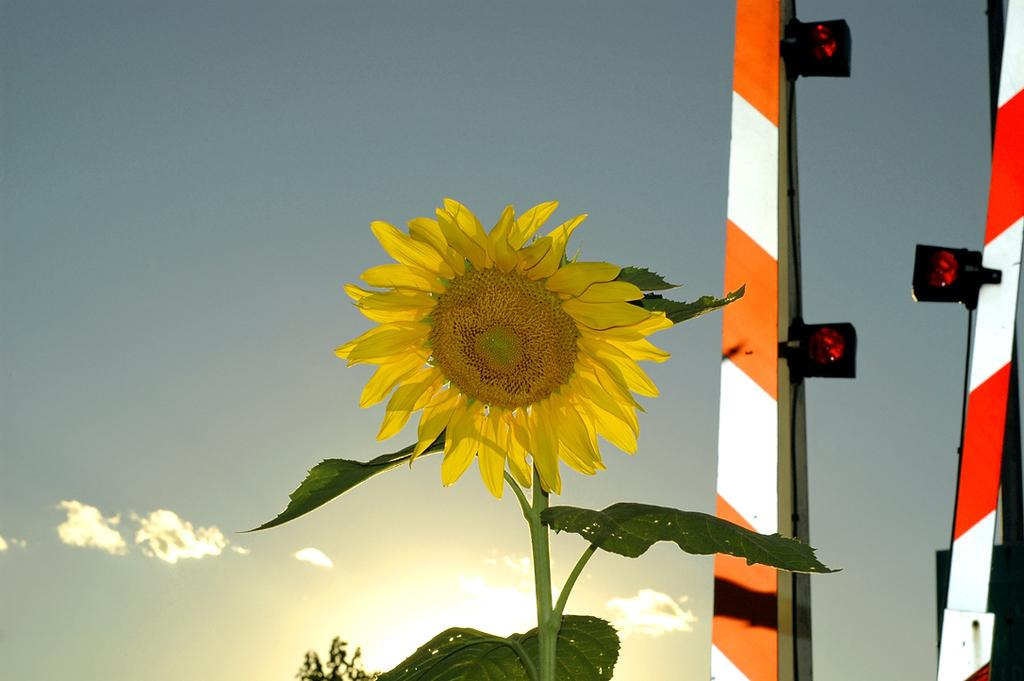What type of plant is in the image? There is a sunflower in the image. What structures can be seen in the image? There are two poles in the image. What can be seen in the background of the image? There is a sky visible in the background of the image. What is the condition of the sky in the image? Clouds are present in the sky. What song is being sung by the kittens in the image? There are no kittens or any indication of singing in the image. 